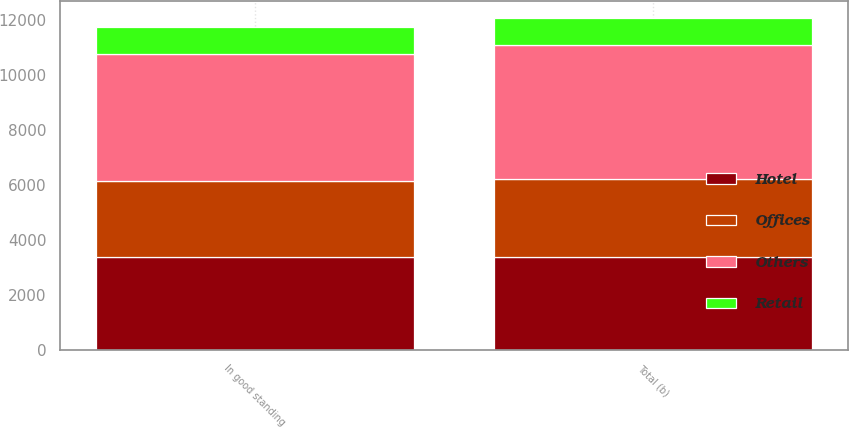Convert chart to OTSL. <chart><loc_0><loc_0><loc_500><loc_500><stacked_bar_chart><ecel><fcel>In good standing<fcel>Total (b)<nl><fcel>Retail<fcel>978<fcel>995<nl><fcel>Offices<fcel>2786<fcel>2839<nl><fcel>Others<fcel>4636<fcel>4888<nl><fcel>Hotel<fcel>3364<fcel>3375<nl></chart> 